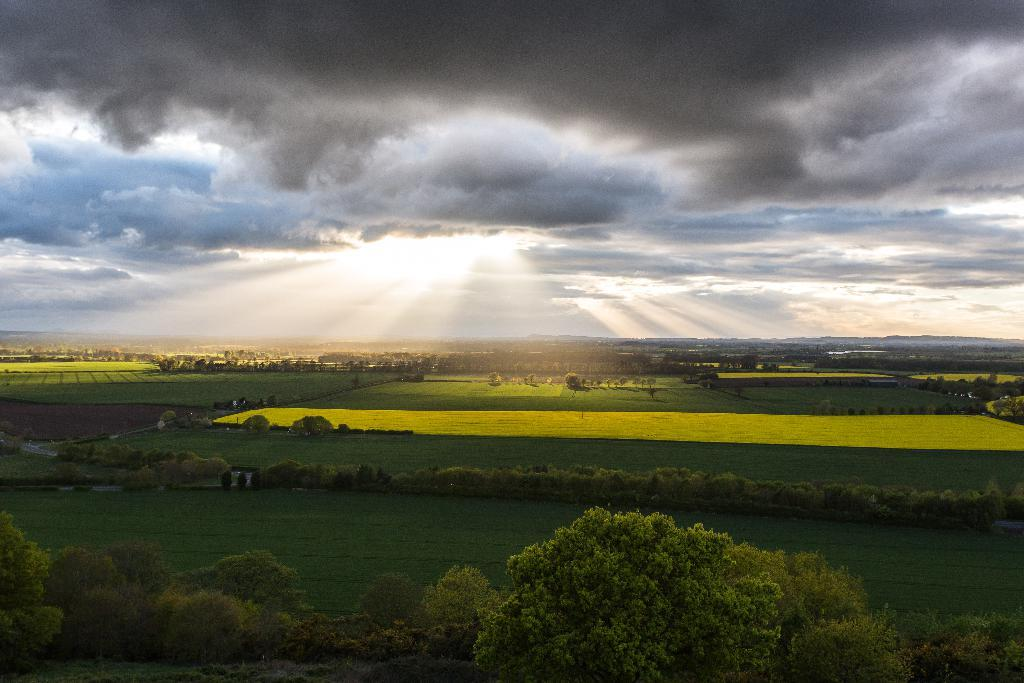What type of image is being described? The image is a landscape. What can be seen in the landscape? There are fields and trees in the image. What is the source of light in the image? Sunlight is visible in the image. What else can be seen in the sky? Clouds are present in the image. How many slaves are visible in the image? There are no slaves present in the image; it is a landscape featuring fields, trees, sunlight, and clouds. What type of crate is being used to transport the trees in the image? There is no crate present in the image, as the trees are growing in their natural environment. 